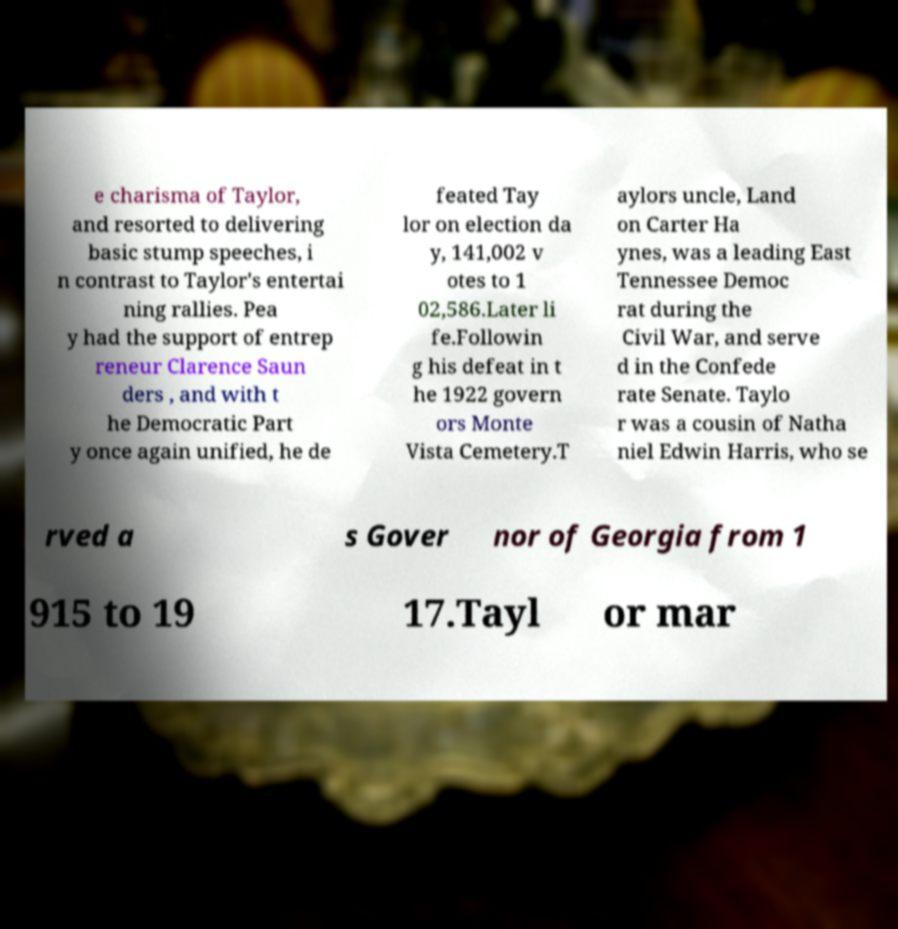Could you extract and type out the text from this image? e charisma of Taylor, and resorted to delivering basic stump speeches, i n contrast to Taylor's entertai ning rallies. Pea y had the support of entrep reneur Clarence Saun ders , and with t he Democratic Part y once again unified, he de feated Tay lor on election da y, 141,002 v otes to 1 02,586.Later li fe.Followin g his defeat in t he 1922 govern ors Monte Vista Cemetery.T aylors uncle, Land on Carter Ha ynes, was a leading East Tennessee Democ rat during the Civil War, and serve d in the Confede rate Senate. Taylo r was a cousin of Natha niel Edwin Harris, who se rved a s Gover nor of Georgia from 1 915 to 19 17.Tayl or mar 